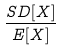<formula> <loc_0><loc_0><loc_500><loc_500>\frac { S D [ X ] } { E [ X ] }</formula> 